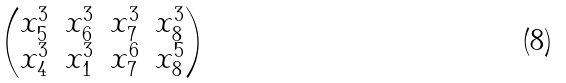<formula> <loc_0><loc_0><loc_500><loc_500>\begin{pmatrix} x _ { 5 } ^ { 3 } & x _ { 6 } ^ { 3 } & x _ { 7 } ^ { 3 } & x _ { 8 } ^ { 3 } \\ x _ { 4 } ^ { 3 } & x _ { 1 } ^ { 3 } & x _ { 7 } ^ { 6 } & x _ { 8 } ^ { 5 } \end{pmatrix}</formula> 